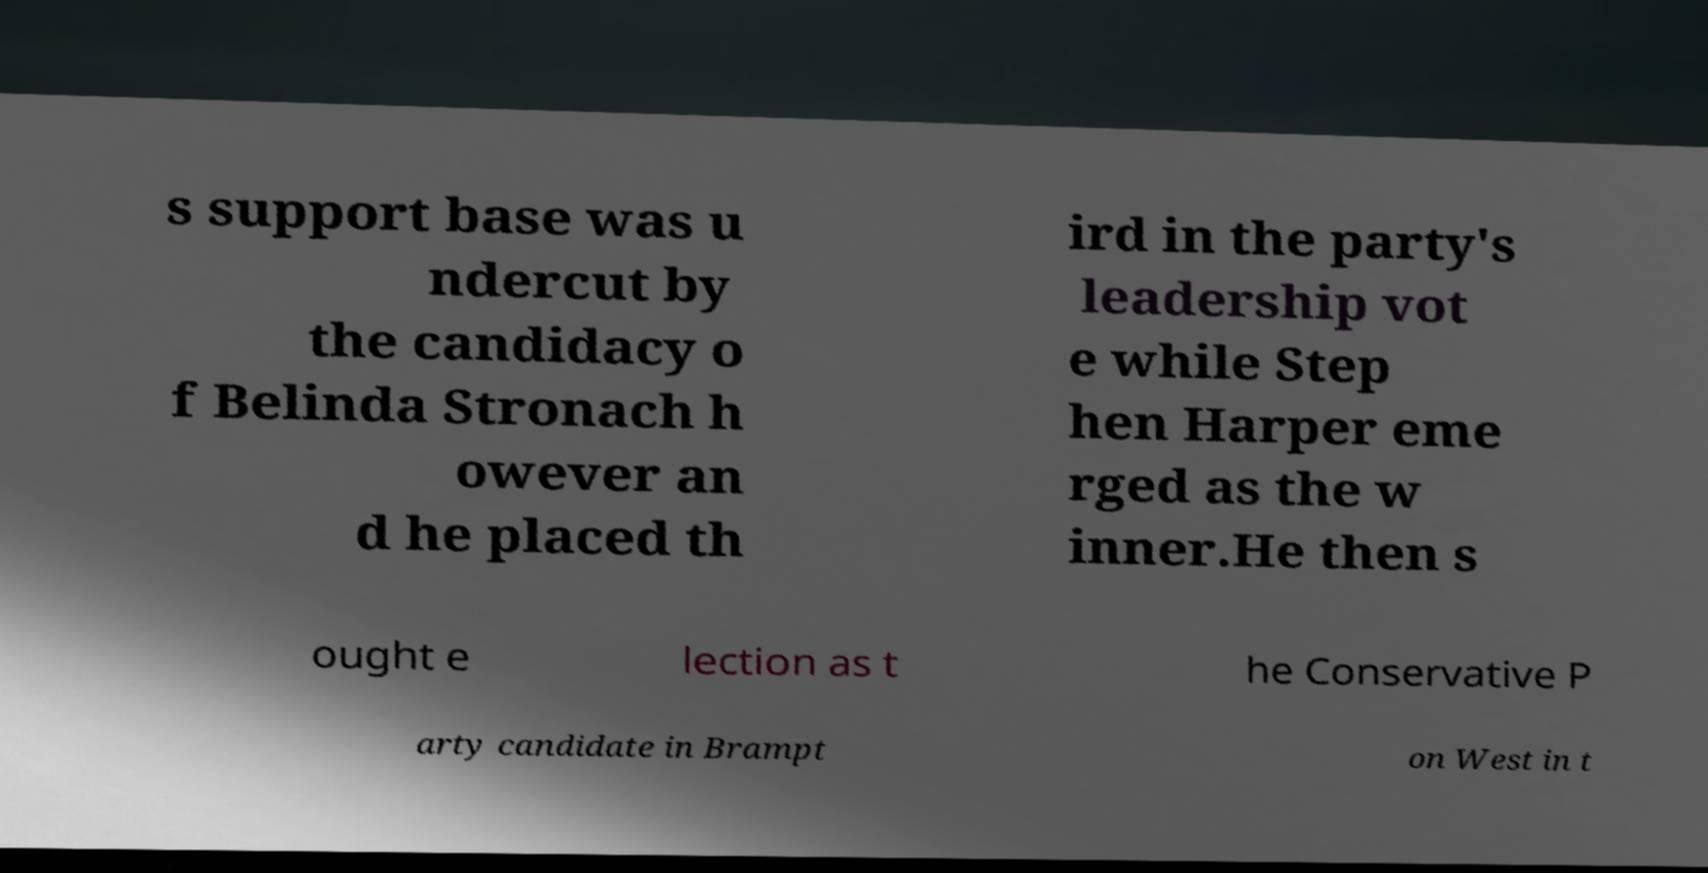Could you assist in decoding the text presented in this image and type it out clearly? s support base was u ndercut by the candidacy o f Belinda Stronach h owever an d he placed th ird in the party's leadership vot e while Step hen Harper eme rged as the w inner.He then s ought e lection as t he Conservative P arty candidate in Brampt on West in t 